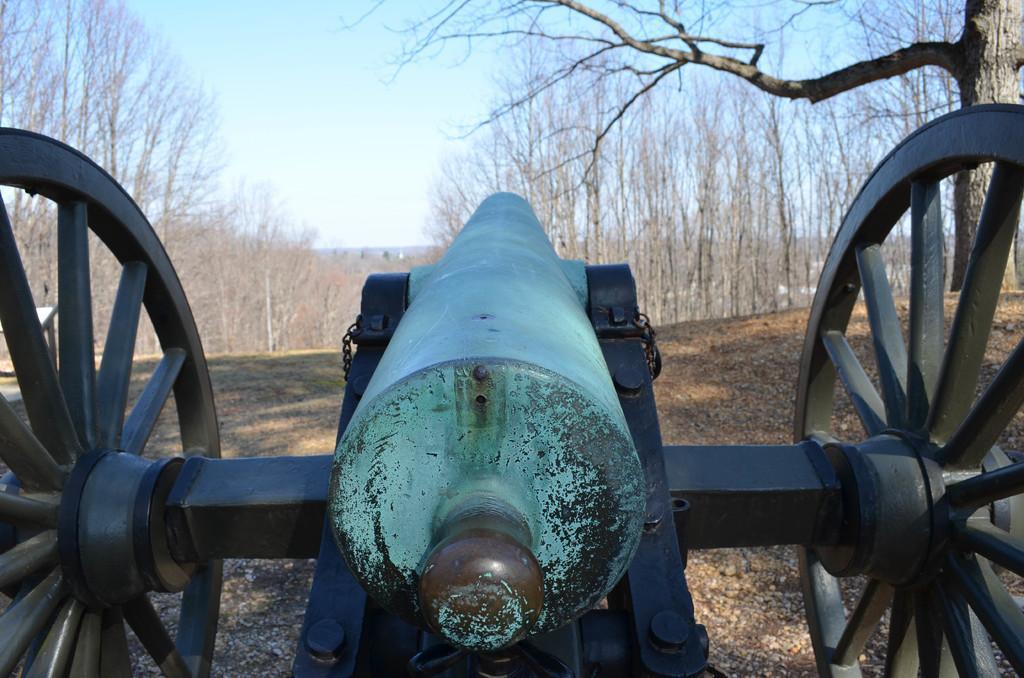Please provide a concise description of this image. In this picture, on the foreground there is a cannon and on the right side there is tree and background is the sky. 